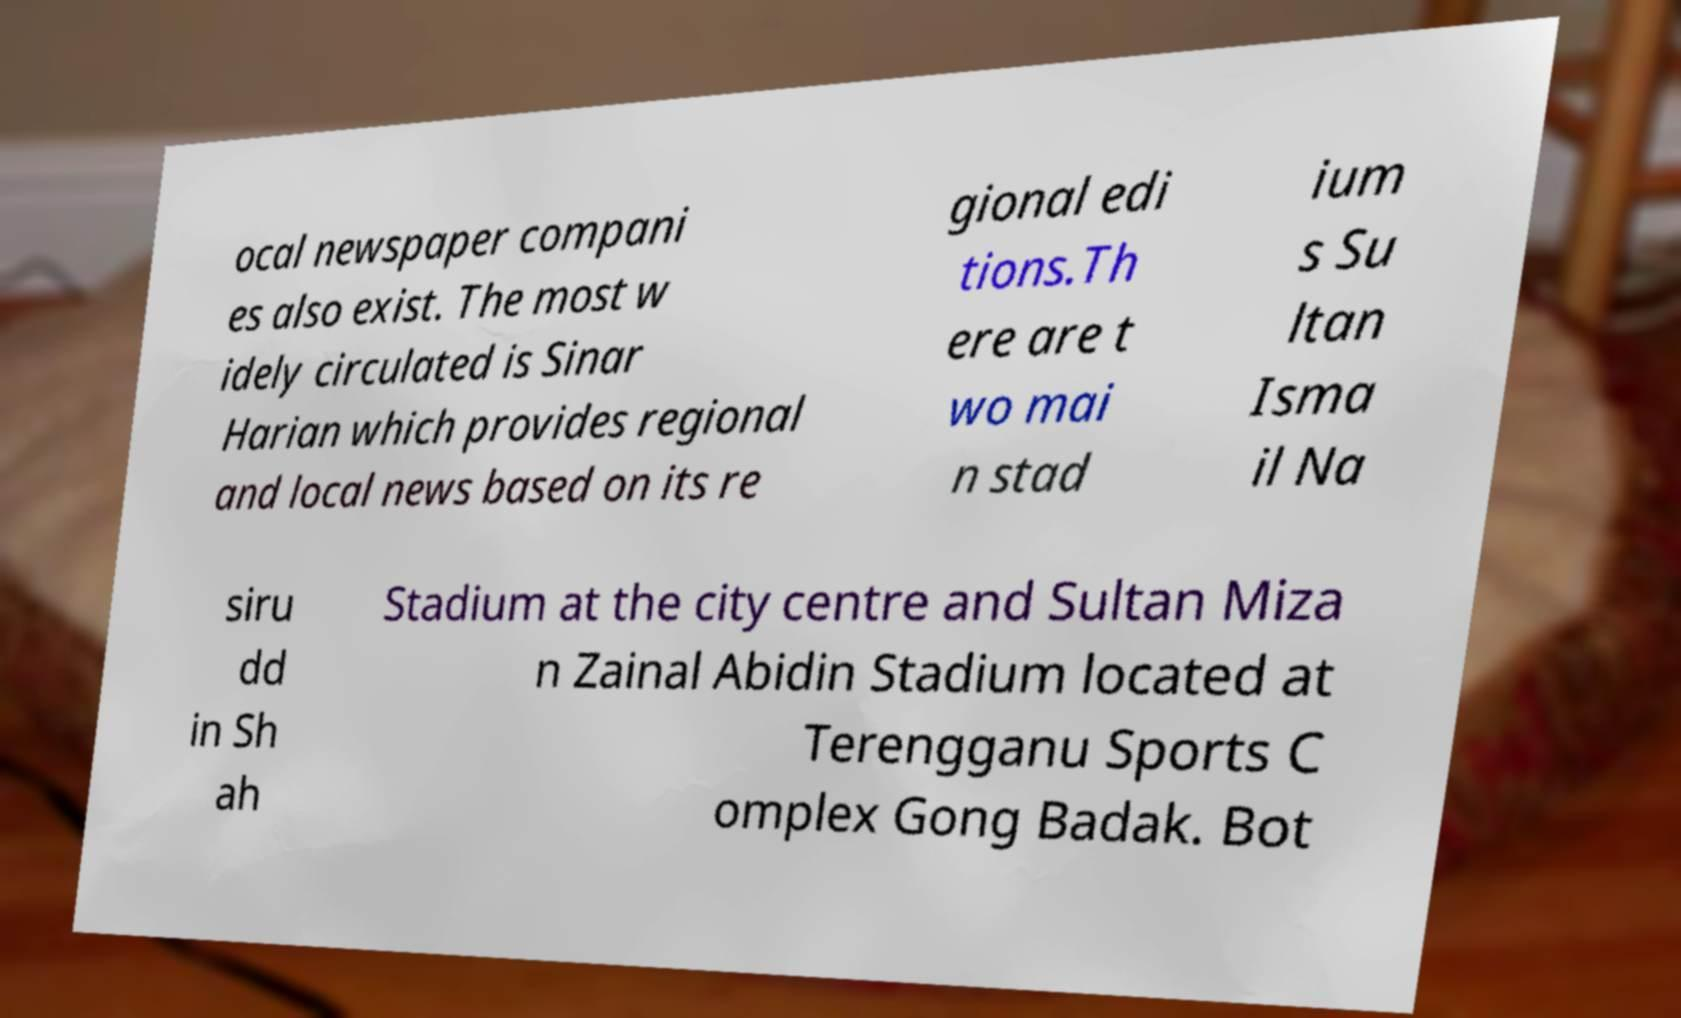Please read and relay the text visible in this image. What does it say? ocal newspaper compani es also exist. The most w idely circulated is Sinar Harian which provides regional and local news based on its re gional edi tions.Th ere are t wo mai n stad ium s Su ltan Isma il Na siru dd in Sh ah Stadium at the city centre and Sultan Miza n Zainal Abidin Stadium located at Terengganu Sports C omplex Gong Badak. Bot 